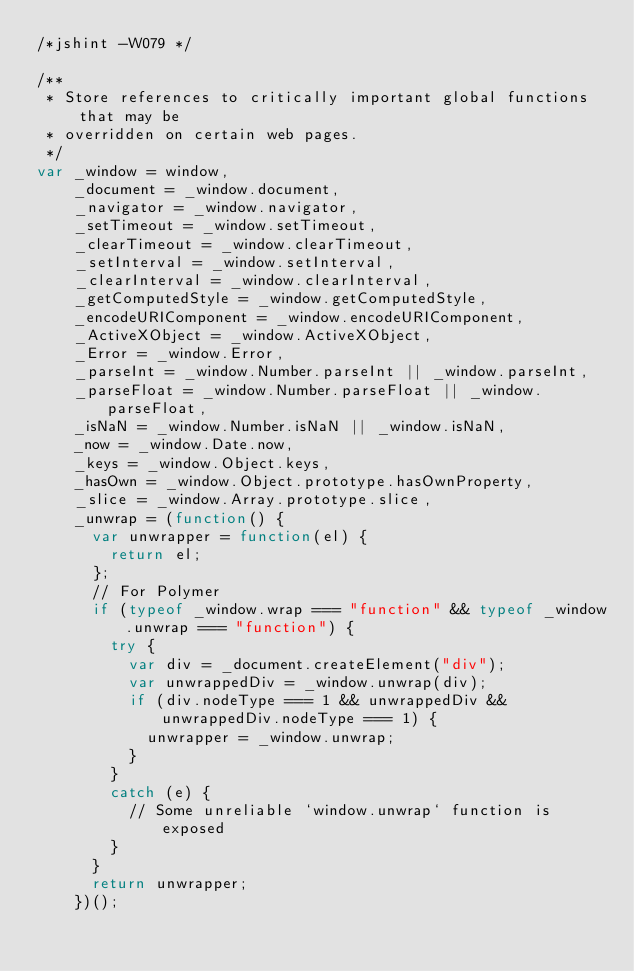<code> <loc_0><loc_0><loc_500><loc_500><_JavaScript_>/*jshint -W079 */

/**
 * Store references to critically important global functions that may be
 * overridden on certain web pages.
 */
var _window = window,
    _document = _window.document,
    _navigator = _window.navigator,
    _setTimeout = _window.setTimeout,
    _clearTimeout = _window.clearTimeout,
    _setInterval = _window.setInterval,
    _clearInterval = _window.clearInterval,
    _getComputedStyle = _window.getComputedStyle,
    _encodeURIComponent = _window.encodeURIComponent,
    _ActiveXObject = _window.ActiveXObject,
    _Error = _window.Error,
    _parseInt = _window.Number.parseInt || _window.parseInt,
    _parseFloat = _window.Number.parseFloat || _window.parseFloat,
    _isNaN = _window.Number.isNaN || _window.isNaN,
    _now = _window.Date.now,
    _keys = _window.Object.keys,
    _hasOwn = _window.Object.prototype.hasOwnProperty,
    _slice = _window.Array.prototype.slice,
    _unwrap = (function() {
      var unwrapper = function(el) {
        return el;
      };
      // For Polymer
      if (typeof _window.wrap === "function" && typeof _window.unwrap === "function") {
        try {
          var div = _document.createElement("div");
          var unwrappedDiv = _window.unwrap(div);
          if (div.nodeType === 1 && unwrappedDiv && unwrappedDiv.nodeType === 1) {
            unwrapper = _window.unwrap;
          }
        }
        catch (e) {
          // Some unreliable `window.unwrap` function is exposed
        }
      }
      return unwrapper;
    })();
</code> 